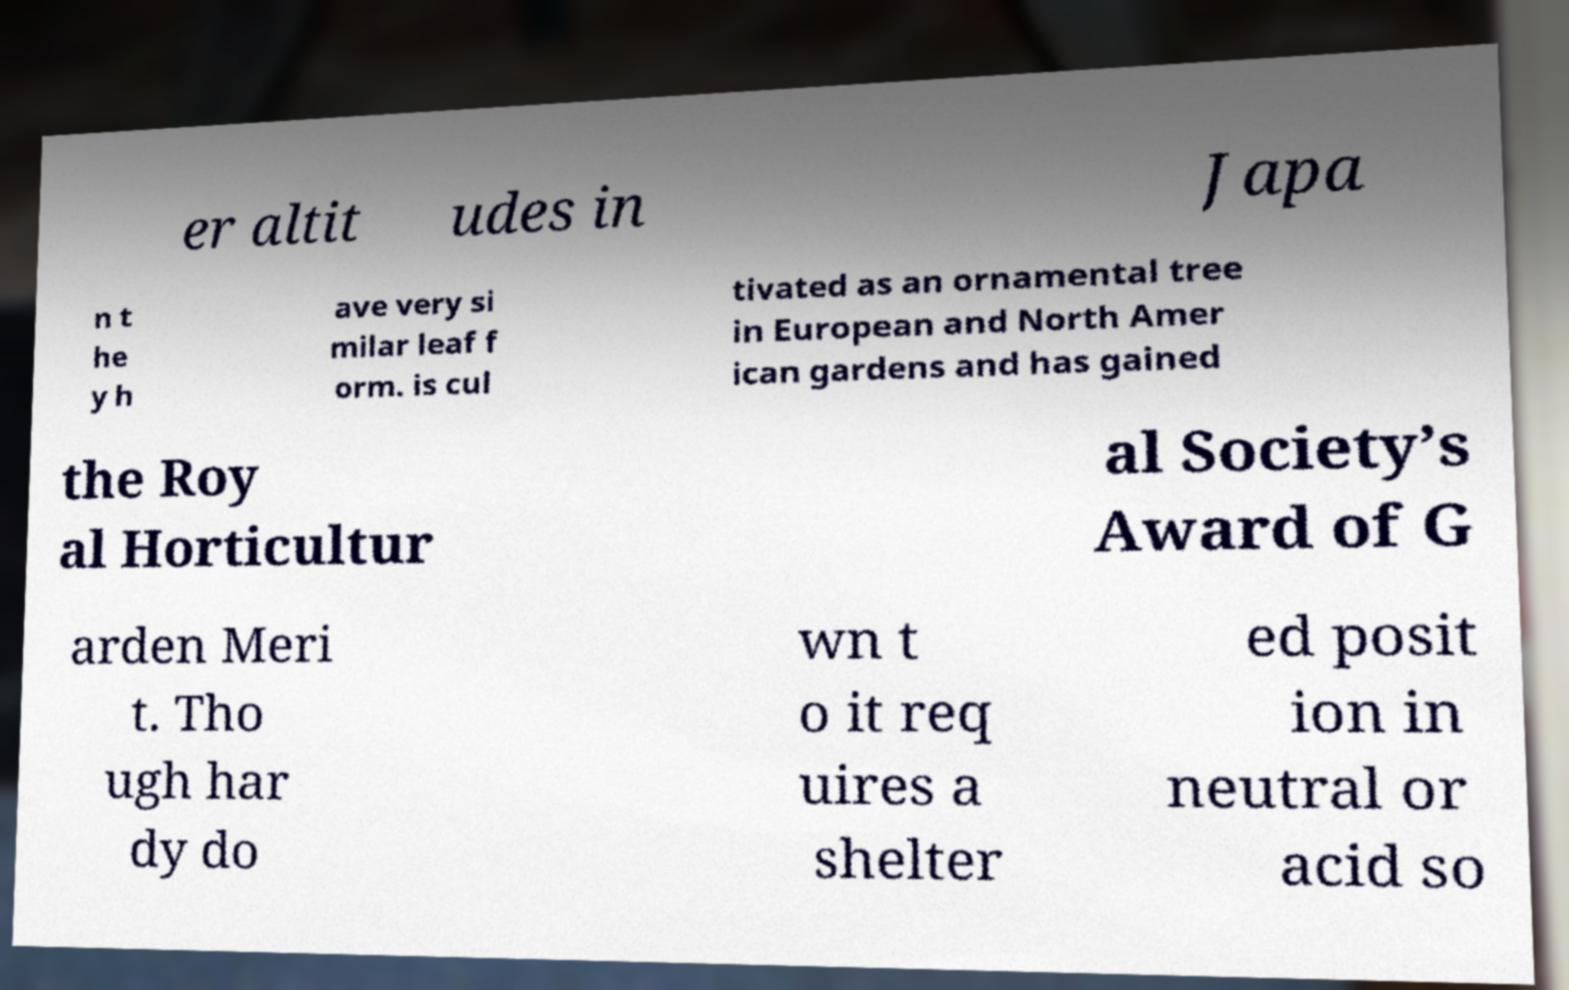Can you read and provide the text displayed in the image?This photo seems to have some interesting text. Can you extract and type it out for me? er altit udes in Japa n t he y h ave very si milar leaf f orm. is cul tivated as an ornamental tree in European and North Amer ican gardens and has gained the Roy al Horticultur al Society’s Award of G arden Meri t. Tho ugh har dy do wn t o it req uires a shelter ed posit ion in neutral or acid so 